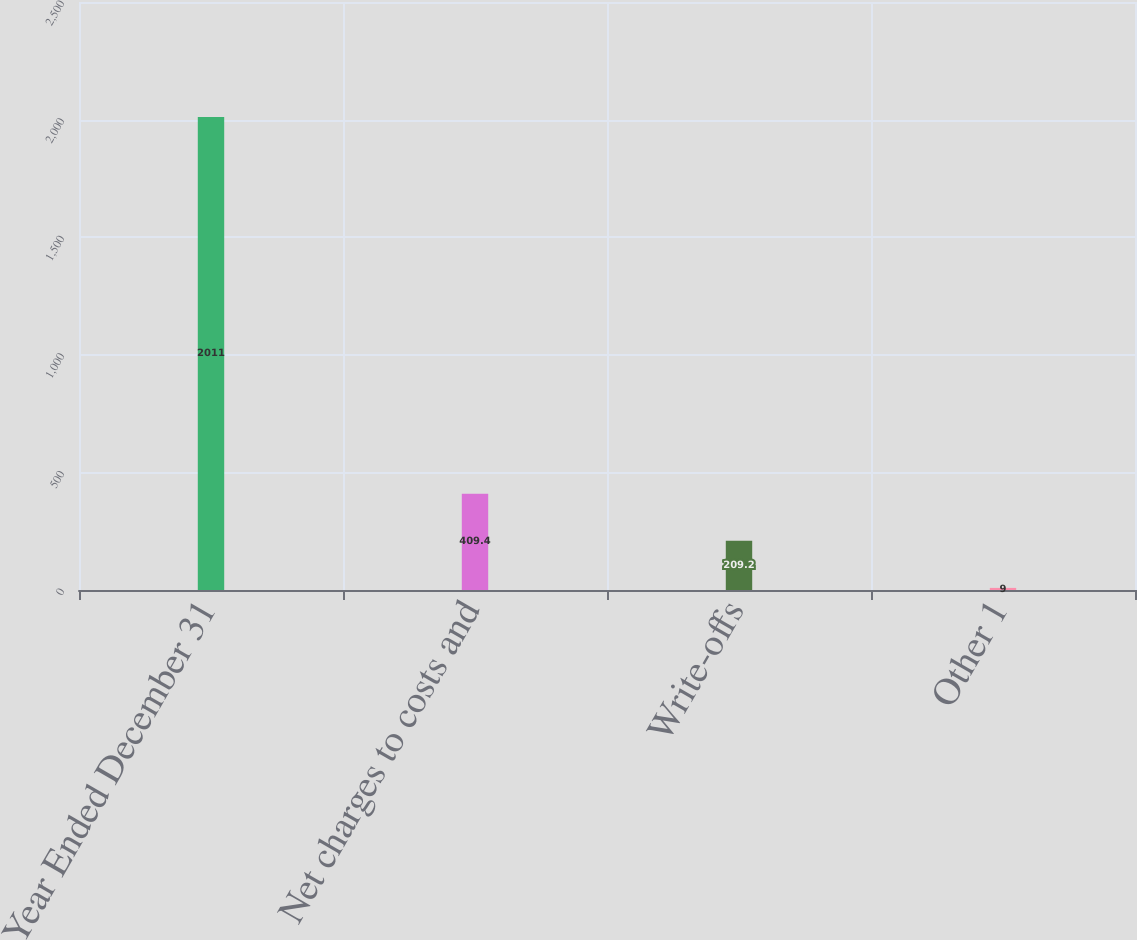Convert chart. <chart><loc_0><loc_0><loc_500><loc_500><bar_chart><fcel>Year Ended December 31<fcel>Net charges to costs and<fcel>Write-offs<fcel>Other 1<nl><fcel>2011<fcel>409.4<fcel>209.2<fcel>9<nl></chart> 